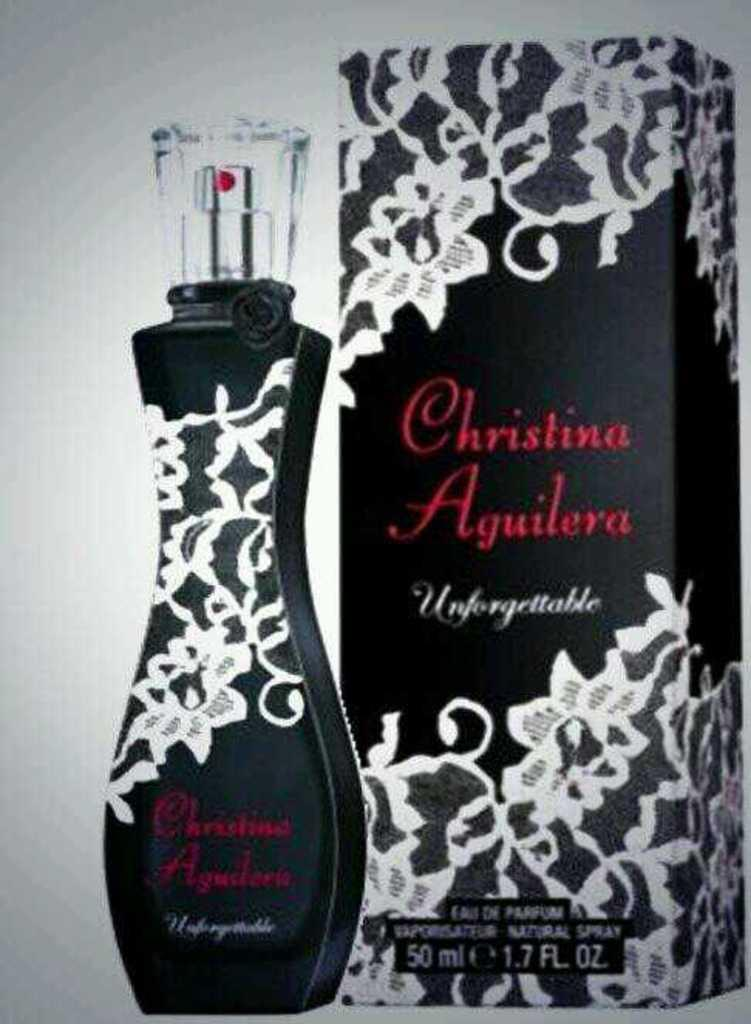<image>
Share a concise interpretation of the image provided. A bottle of Cristina Aguilera brand perfume in a black bottle with white lace design beside the packaging 